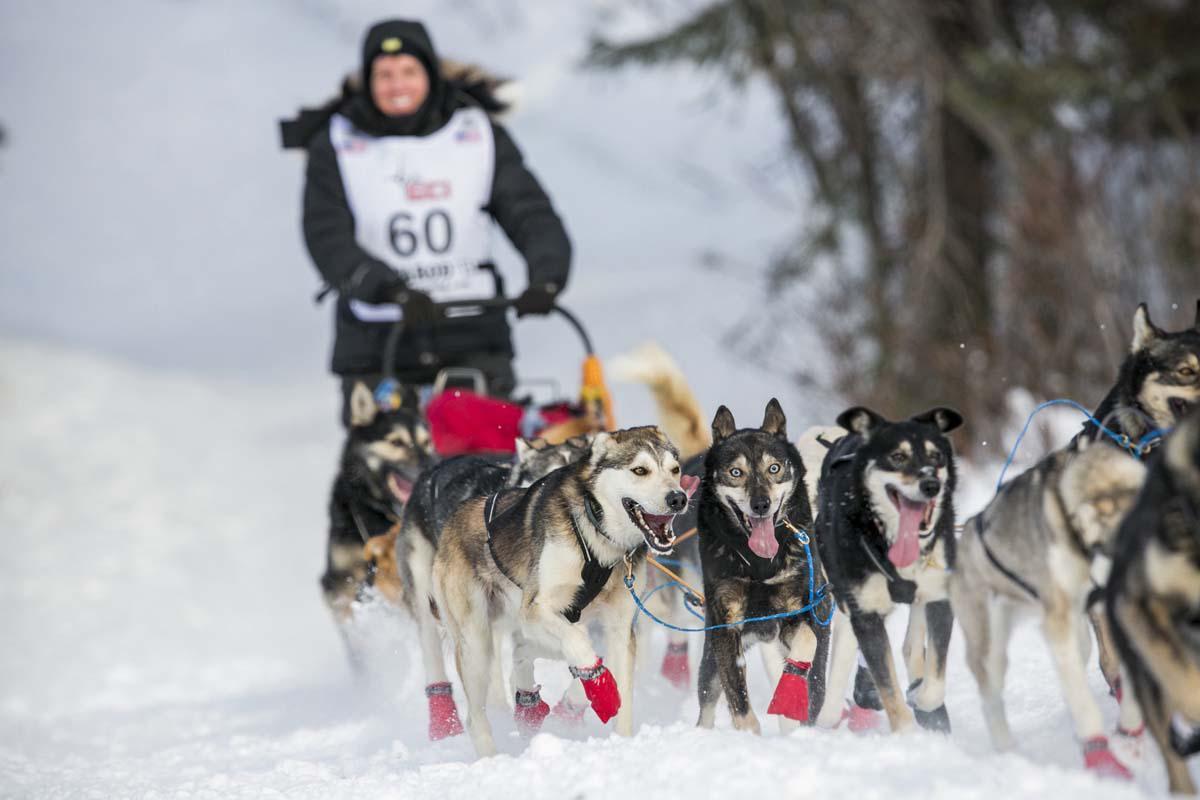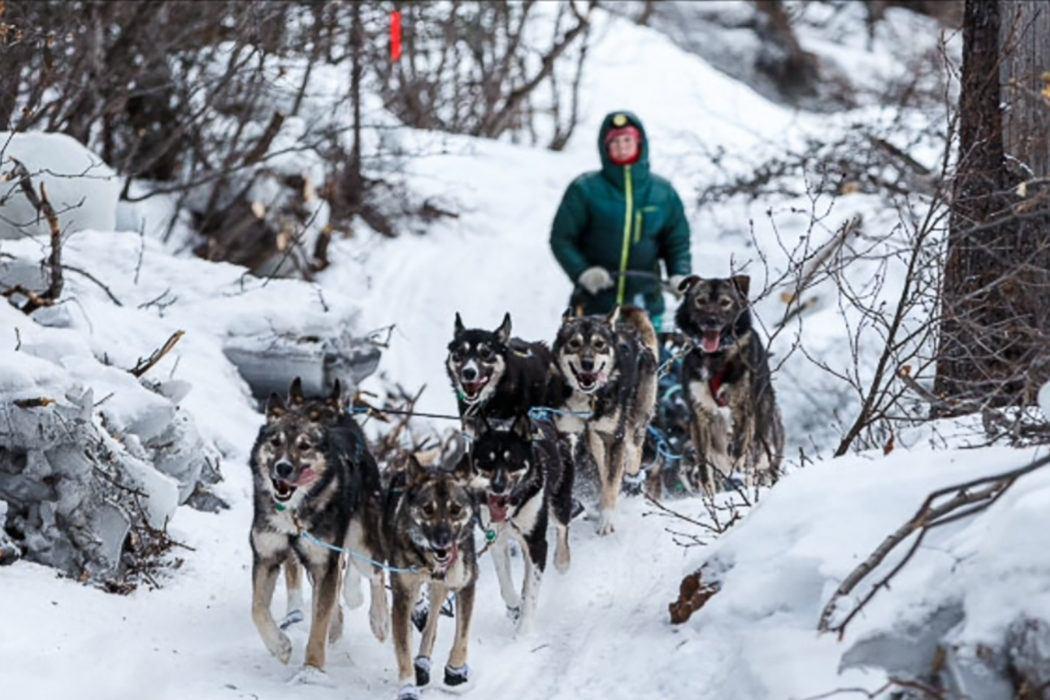The first image is the image on the left, the second image is the image on the right. Examine the images to the left and right. Is the description "A team of dogs wear the same non-black color of booties." accurate? Answer yes or no. Yes. The first image is the image on the left, the second image is the image on the right. Assess this claim about the two images: "Some dogs are wearing gloves that aren't black.". Correct or not? Answer yes or no. Yes. 